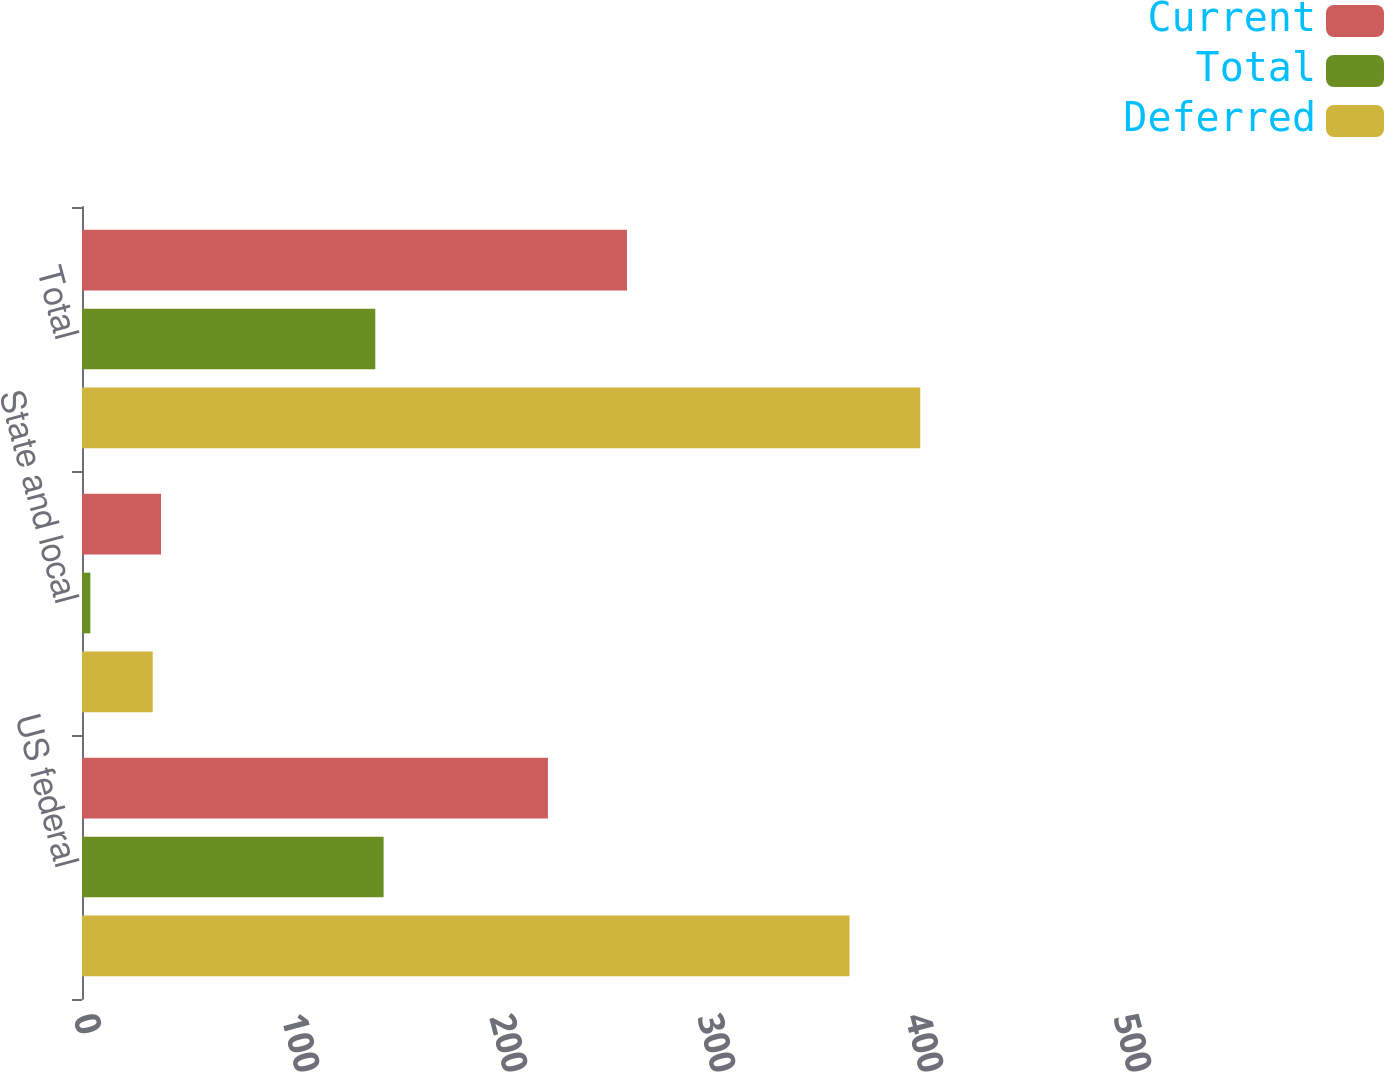Convert chart to OTSL. <chart><loc_0><loc_0><loc_500><loc_500><stacked_bar_chart><ecel><fcel>US federal<fcel>State and local<fcel>Total<nl><fcel>Current<fcel>224<fcel>38<fcel>262<nl><fcel>Total<fcel>145<fcel>4<fcel>141<nl><fcel>Deferred<fcel>369<fcel>34<fcel>403<nl></chart> 